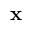Convert formula to latex. <formula><loc_0><loc_0><loc_500><loc_500>{ x }</formula> 